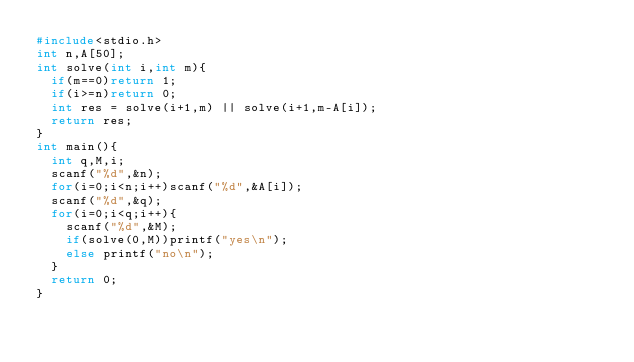Convert code to text. <code><loc_0><loc_0><loc_500><loc_500><_C_>#include<stdio.h>
int n,A[50];
int solve(int i,int m){
  if(m==0)return 1;
  if(i>=n)return 0;
  int res = solve(i+1,m) || solve(i+1,m-A[i]);
  return res;
}
int main(){
  int q,M,i;
  scanf("%d",&n);
  for(i=0;i<n;i++)scanf("%d",&A[i]);
  scanf("%d",&q);
  for(i=0;i<q;i++){
    scanf("%d",&M);
    if(solve(0,M))printf("yes\n");
    else printf("no\n");
  }
  return 0;
}
</code> 